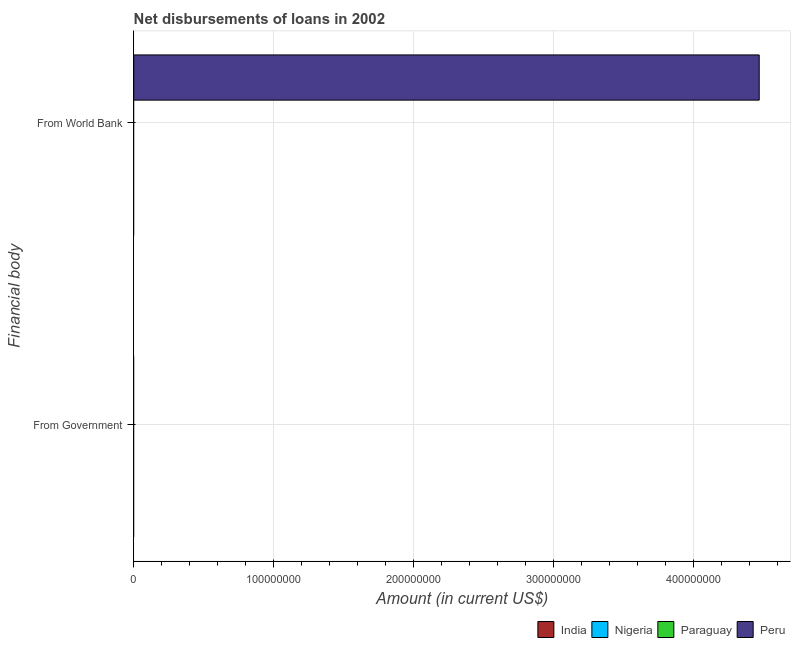Are the number of bars per tick equal to the number of legend labels?
Offer a terse response. No. Are the number of bars on each tick of the Y-axis equal?
Offer a terse response. No. What is the label of the 2nd group of bars from the top?
Your answer should be compact. From Government. Across all countries, what is the maximum net disbursements of loan from world bank?
Give a very brief answer. 4.47e+08. What is the total net disbursements of loan from world bank in the graph?
Your answer should be compact. 4.47e+08. What is the difference between the net disbursements of loan from world bank in Peru and the net disbursements of loan from government in Nigeria?
Your answer should be very brief. 4.47e+08. What is the average net disbursements of loan from government per country?
Make the answer very short. 0. In how many countries, is the net disbursements of loan from government greater than 100000000 US$?
Keep it short and to the point. 0. Are all the bars in the graph horizontal?
Offer a very short reply. Yes. How many countries are there in the graph?
Provide a succinct answer. 4. What is the difference between two consecutive major ticks on the X-axis?
Provide a succinct answer. 1.00e+08. Are the values on the major ticks of X-axis written in scientific E-notation?
Offer a terse response. No. How many legend labels are there?
Offer a terse response. 4. How are the legend labels stacked?
Ensure brevity in your answer.  Horizontal. What is the title of the graph?
Your response must be concise. Net disbursements of loans in 2002. What is the label or title of the X-axis?
Provide a short and direct response. Amount (in current US$). What is the label or title of the Y-axis?
Offer a very short reply. Financial body. What is the Amount (in current US$) of India in From Government?
Your answer should be very brief. 0. What is the Amount (in current US$) of Paraguay in From Government?
Offer a terse response. 0. What is the Amount (in current US$) in Peru in From Government?
Ensure brevity in your answer.  0. What is the Amount (in current US$) in Nigeria in From World Bank?
Keep it short and to the point. 0. What is the Amount (in current US$) in Peru in From World Bank?
Your answer should be compact. 4.47e+08. Across all Financial body, what is the maximum Amount (in current US$) of Peru?
Offer a very short reply. 4.47e+08. Across all Financial body, what is the minimum Amount (in current US$) of Peru?
Offer a very short reply. 0. What is the total Amount (in current US$) in Nigeria in the graph?
Offer a very short reply. 0. What is the total Amount (in current US$) in Paraguay in the graph?
Give a very brief answer. 0. What is the total Amount (in current US$) in Peru in the graph?
Offer a very short reply. 4.47e+08. What is the average Amount (in current US$) of Peru per Financial body?
Give a very brief answer. 2.24e+08. What is the difference between the highest and the lowest Amount (in current US$) of Peru?
Provide a short and direct response. 4.47e+08. 